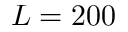Convert formula to latex. <formula><loc_0><loc_0><loc_500><loc_500>L = 2 0 0</formula> 